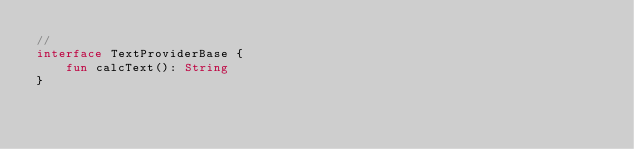<code> <loc_0><loc_0><loc_500><loc_500><_Kotlin_>//
interface TextProviderBase {
    fun calcText(): String
}</code> 